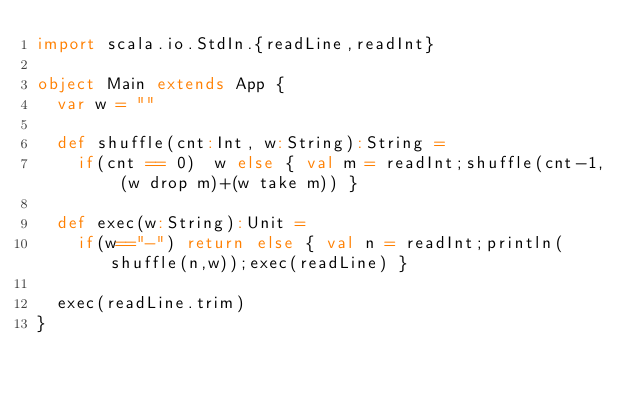<code> <loc_0><loc_0><loc_500><loc_500><_Scala_>import scala.io.StdIn.{readLine,readInt}

object Main extends App {
  var w = ""

  def shuffle(cnt:Int, w:String):String =
    if(cnt == 0)  w else { val m = readInt;shuffle(cnt-1, (w drop m)+(w take m)) }

  def exec(w:String):Unit =
    if(w=="-") return else { val n = readInt;println(shuffle(n,w));exec(readLine) }

  exec(readLine.trim)
}</code> 